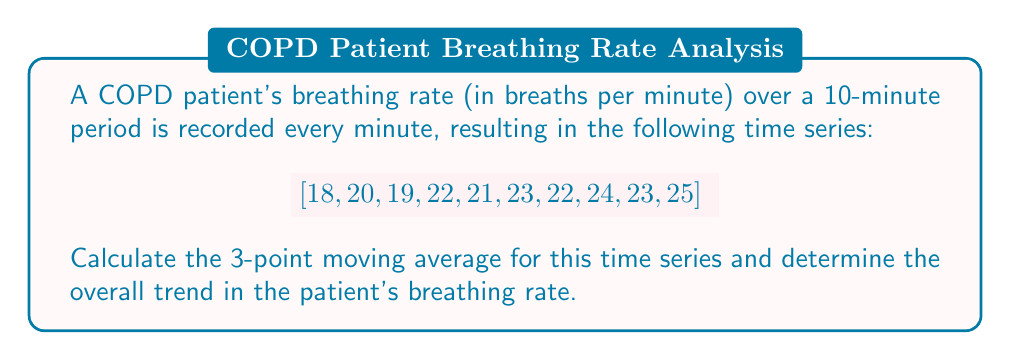Teach me how to tackle this problem. 1) To calculate the 3-point moving average, we use the formula:

   $$ MA_t = \frac{1}{3}(x_{t-1} + x_t + x_{t+1}) $$

   where $MA_t$ is the moving average at time $t$, and $x_t$ is the value at time $t$.

2) Calculate the moving averages:
   
   $MA_2 = \frac{1}{3}(18 + 20 + 19) = 19$
   $MA_3 = \frac{1}{3}(20 + 19 + 22) = 20.33$
   $MA_4 = \frac{1}{3}(19 + 22 + 21) = 20.67$
   $MA_5 = \frac{1}{3}(22 + 21 + 23) = 22$
   $MA_6 = \frac{1}{3}(21 + 23 + 22) = 22$
   $MA_7 = \frac{1}{3}(23 + 22 + 24) = 23$
   $MA_8 = \frac{1}{3}(22 + 24 + 23) = 23$
   $MA_9 = \frac{1}{3}(24 + 23 + 25) = 24$

3) The resulting 3-point moving average series is:

   $$ [19, 20.33, 20.67, 22, 22, 23, 23, 24] $$

4) To determine the overall trend, we can calculate the slope of the line of best fit using the least squares method:

   $$ m = \frac{n\sum xy - \sum x \sum y}{n\sum x^2 - (\sum x)^2} $$

   where $x$ represents time (1 to 8) and $y$ represents the moving averages.

5) Calculating the required sums:
   $\sum x = 36$, $\sum y = 174$, $\sum xy = 857$, $\sum x^2 = 204$, $n = 8$

6) Plugging into the formula:

   $$ m = \frac{8(857) - 36(174)}{8(204) - 36^2} = \frac{6856 - 6264}{1632 - 1296} = \frac{592}{336} = 1.76 $$

The positive slope indicates an increasing trend in the patient's breathing rate.
Answer: Increasing trend with slope 1.76 breaths/min² 